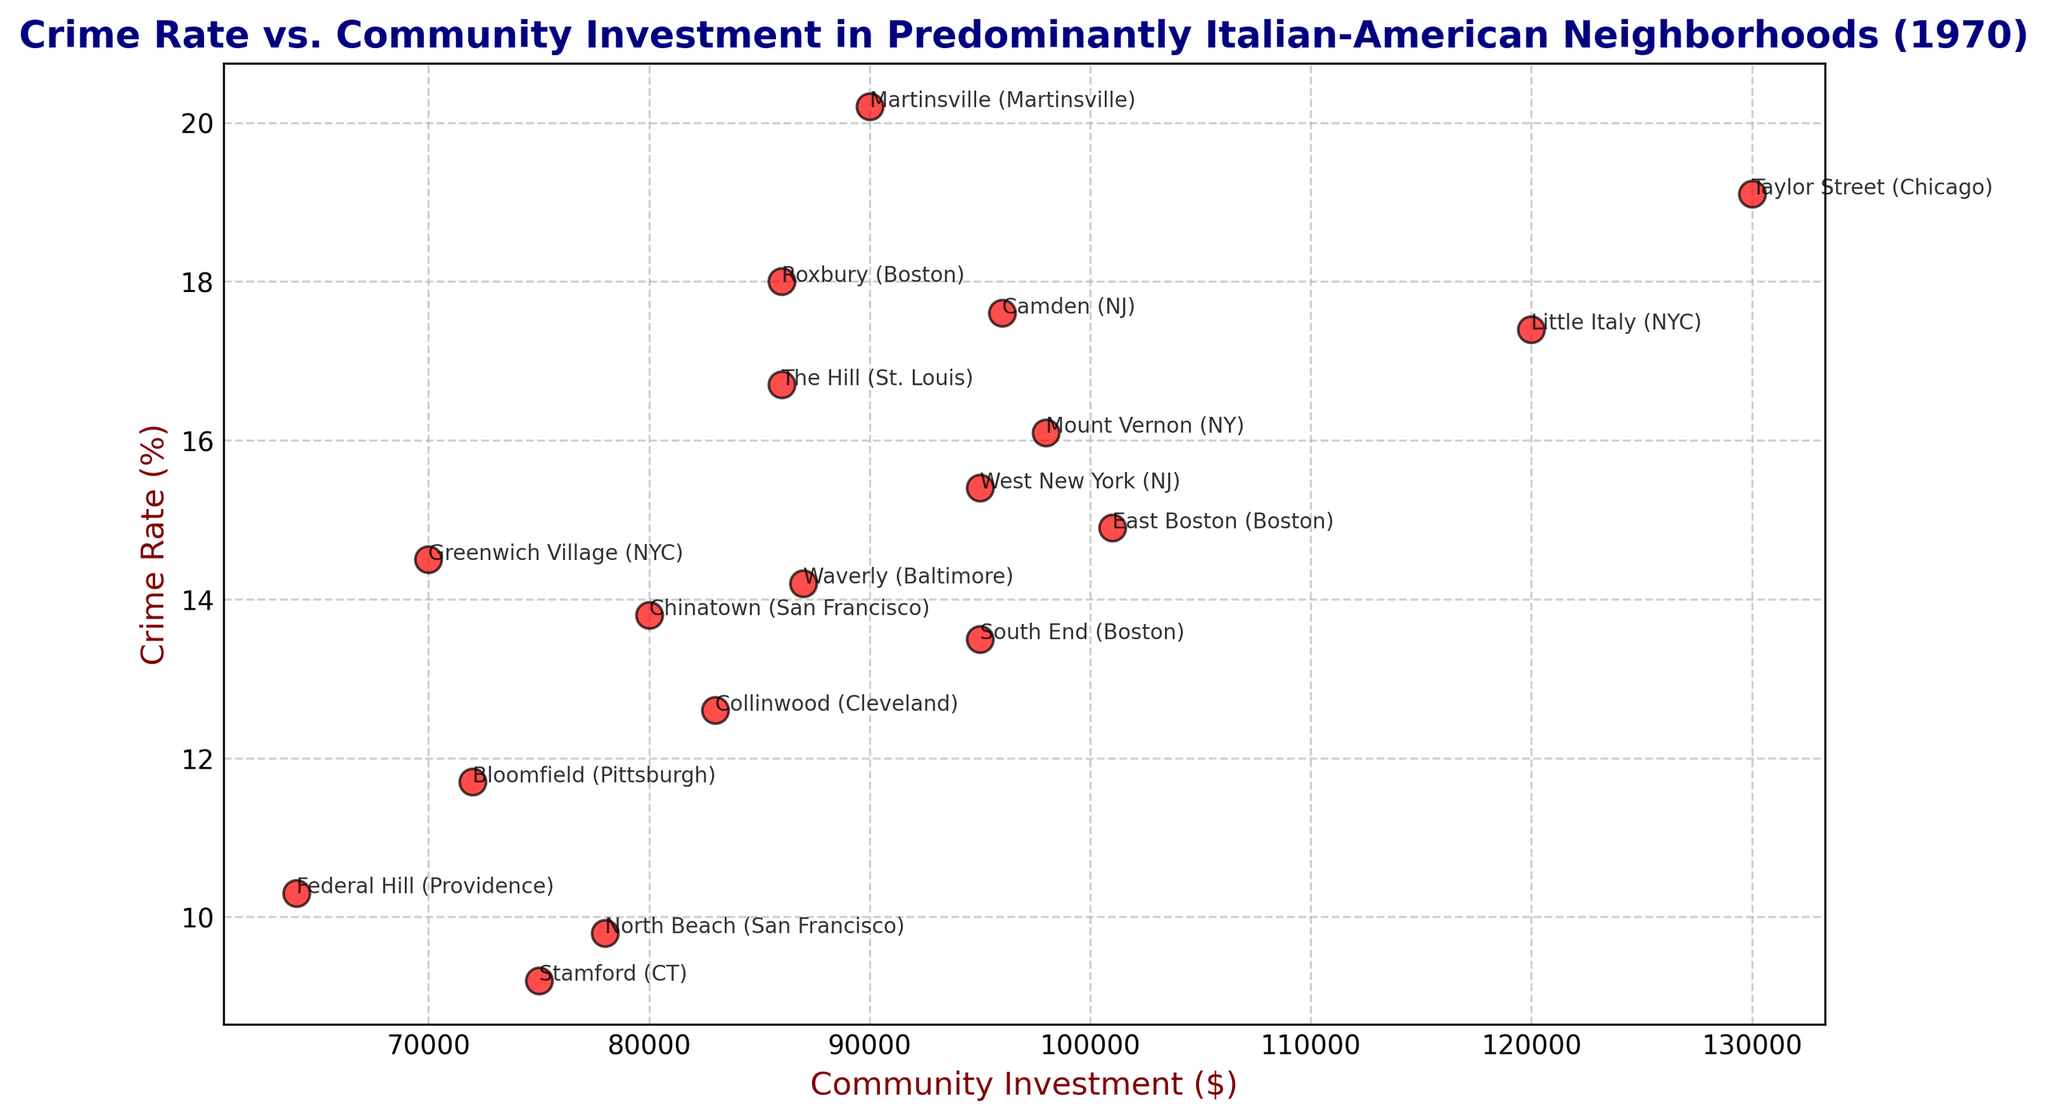What is the community with the highest crime rate? By observing the scatter plot, the point with the highest crime rate will be the topmost point. Looking at the annotations, "Martinsville" shows the highest position on the y-axis.
Answer: Martinsville What can be said about the relationship between community investment and crime rate in the graph? Visually, you can examine the scatter points to see the general trend. There doesn’t appear to be a strong correlation as the points are fairly scattered without a clear upward or downward trend.
Answer: No clear correlation Which neighborhood has the lowest community investment and what is its crime rate? Find the leftmost point on the graph which represents the lowest community investment. The annotation for this point indicates "Federal Hill" and observing its y-coordinate provides the crime rate.
Answer: Federal Hill, 10.3% Compare the crime rates of North Beach (San Francisco) and The Hill (St. Louis). Identify the points for North Beach (San Francisco) and The Hill (St. Louis) on the graph and compare their y-coordinates. North Beach has a lower y-coordinate value.
Answer: North Beach, 9.8%; The Hill, 16.7% Which neighborhood has the highest community investment? By identifying the rightmost point on the x-axis, we see that the neighborhood with the highest community investment is "Taylor Street (Chicago)".
Answer: Taylor Street (Chicago), $130,000 What's the average crime rate in neighborhoods with community investment over $100,000? Look at points on the right side where community investment is greater than $100,000 – "Little Italy (NYC)," "East Boston (Boston)," "Mount Vernon (NY)," "Taylor Street (Chicago)," "Camden (NJ)," and calculate their average y-coordinates. (17.4 + 14.9 + 16.1 + 19.1 + 17.6) / 5 = 17
Answer: 17% Is there a neighborhood with both high community investment and low crime rate? Look for points on the graph that are on the right (high community investment) but also low on the y-axis (low crime rate). "Stamford (CT)" fits this description.
Answer: Stamford (CT) Which neighborhoods have crime rates between 13% and 15%? Identify points on the graph where the y-coordinate falls between 13% and 15%. These neighborhoods are "South End (Boston)," "East Boston (Boston)," "Waverly (Baltimore)," and "Chinatown (San Francisco)."
Answer: South End (Boston), East Boston (Boston), Waverly (Baltimore), Chinatown (San Francisco) What are the three neighborhoods with the lowest crime rates? Identify the three lowest points on the y-axis and reference their annotations. "Stamford (CT)," "North Beach (San Francisco)," and "Federal Hill (Providence)."
Answer: Stamford (CT), North Beach (San Francisco), Federal Hill (Providence) What is the difference in crime rate between little Italy (NYC) and Roxbury (Boston)? Find the points corresponding to these neighborhoods and calculate the difference in their y-coordinates. The difference is 18.0% - 17.4% = 0.6%.
Answer: 0.6% 